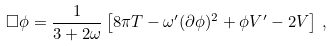<formula> <loc_0><loc_0><loc_500><loc_500>\square \phi = \frac { 1 } { 3 + 2 \omega } \left [ 8 \pi T - \omega ^ { \prime } ( \partial \phi ) ^ { 2 } + \phi V ^ { \prime } - 2 V \right ] \, ,</formula> 